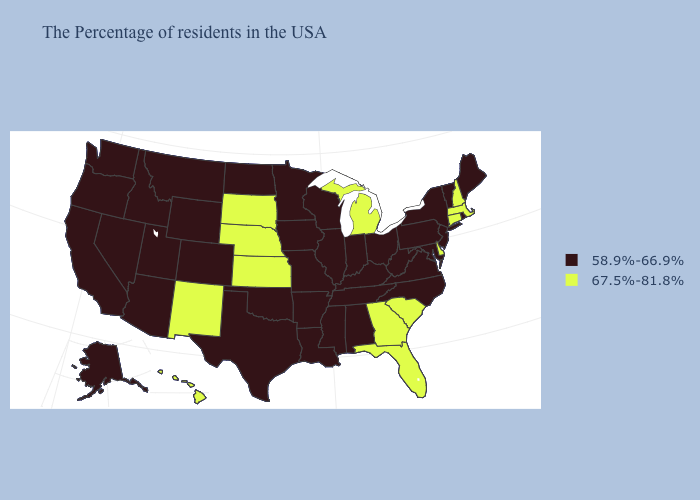Among the states that border North Dakota , which have the highest value?
Quick response, please. South Dakota. What is the value of Oregon?
Concise answer only. 58.9%-66.9%. Does South Carolina have the highest value in the USA?
Write a very short answer. Yes. What is the lowest value in states that border Missouri?
Short answer required. 58.9%-66.9%. Which states have the lowest value in the West?
Be succinct. Wyoming, Colorado, Utah, Montana, Arizona, Idaho, Nevada, California, Washington, Oregon, Alaska. Does the map have missing data?
Short answer required. No. Does Oklahoma have the same value as Georgia?
Quick response, please. No. What is the highest value in the USA?
Quick response, please. 67.5%-81.8%. Name the states that have a value in the range 67.5%-81.8%?
Be succinct. Massachusetts, New Hampshire, Connecticut, Delaware, South Carolina, Florida, Georgia, Michigan, Kansas, Nebraska, South Dakota, New Mexico, Hawaii. Does Florida have the lowest value in the USA?
Answer briefly. No. What is the value of South Dakota?
Write a very short answer. 67.5%-81.8%. Name the states that have a value in the range 67.5%-81.8%?
Be succinct. Massachusetts, New Hampshire, Connecticut, Delaware, South Carolina, Florida, Georgia, Michigan, Kansas, Nebraska, South Dakota, New Mexico, Hawaii. Does the first symbol in the legend represent the smallest category?
Concise answer only. Yes. Name the states that have a value in the range 67.5%-81.8%?
Short answer required. Massachusetts, New Hampshire, Connecticut, Delaware, South Carolina, Florida, Georgia, Michigan, Kansas, Nebraska, South Dakota, New Mexico, Hawaii. Name the states that have a value in the range 67.5%-81.8%?
Write a very short answer. Massachusetts, New Hampshire, Connecticut, Delaware, South Carolina, Florida, Georgia, Michigan, Kansas, Nebraska, South Dakota, New Mexico, Hawaii. 